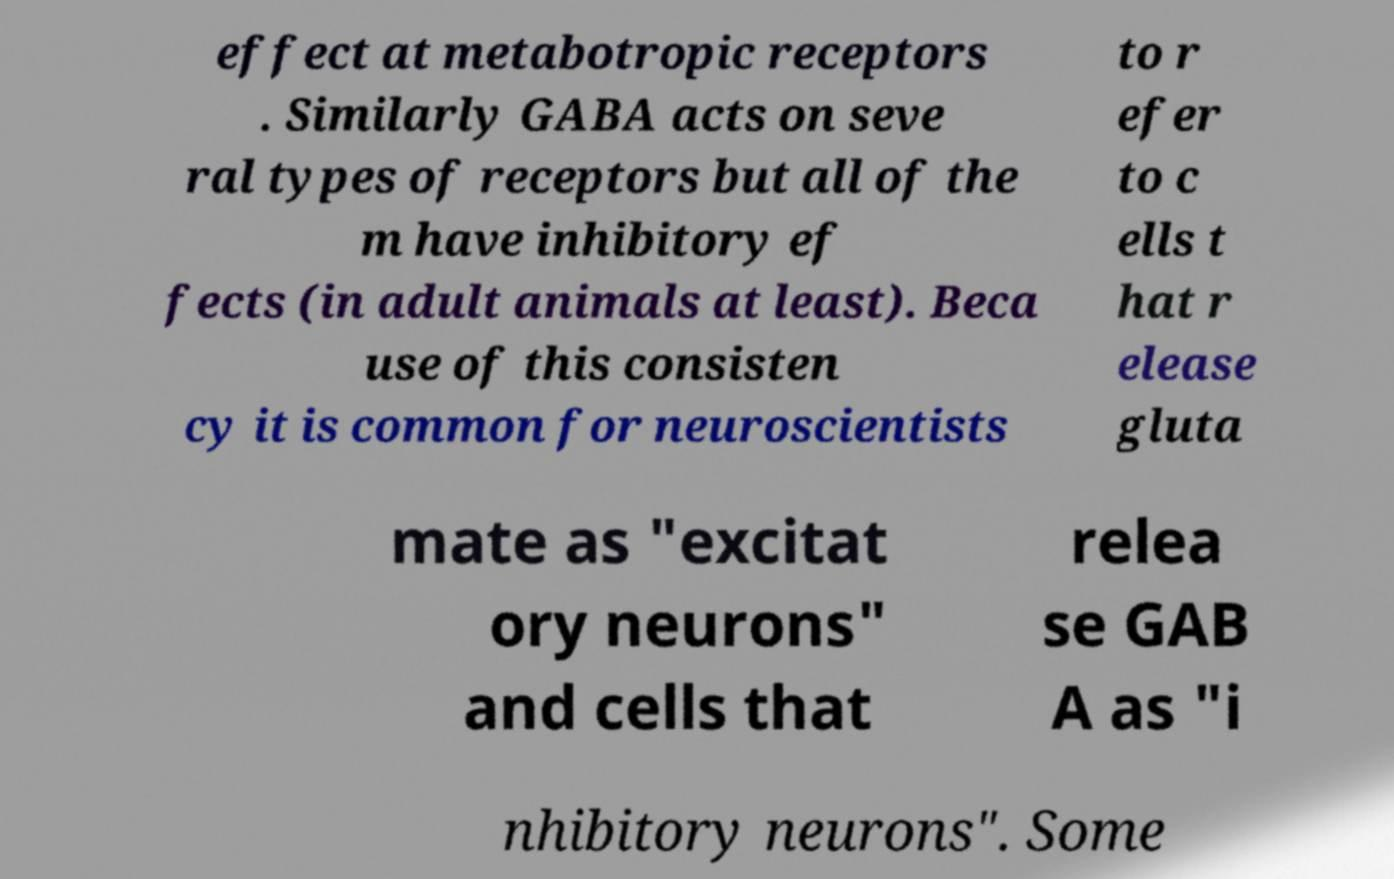Could you assist in decoding the text presented in this image and type it out clearly? effect at metabotropic receptors . Similarly GABA acts on seve ral types of receptors but all of the m have inhibitory ef fects (in adult animals at least). Beca use of this consisten cy it is common for neuroscientists to r efer to c ells t hat r elease gluta mate as "excitat ory neurons" and cells that relea se GAB A as "i nhibitory neurons". Some 